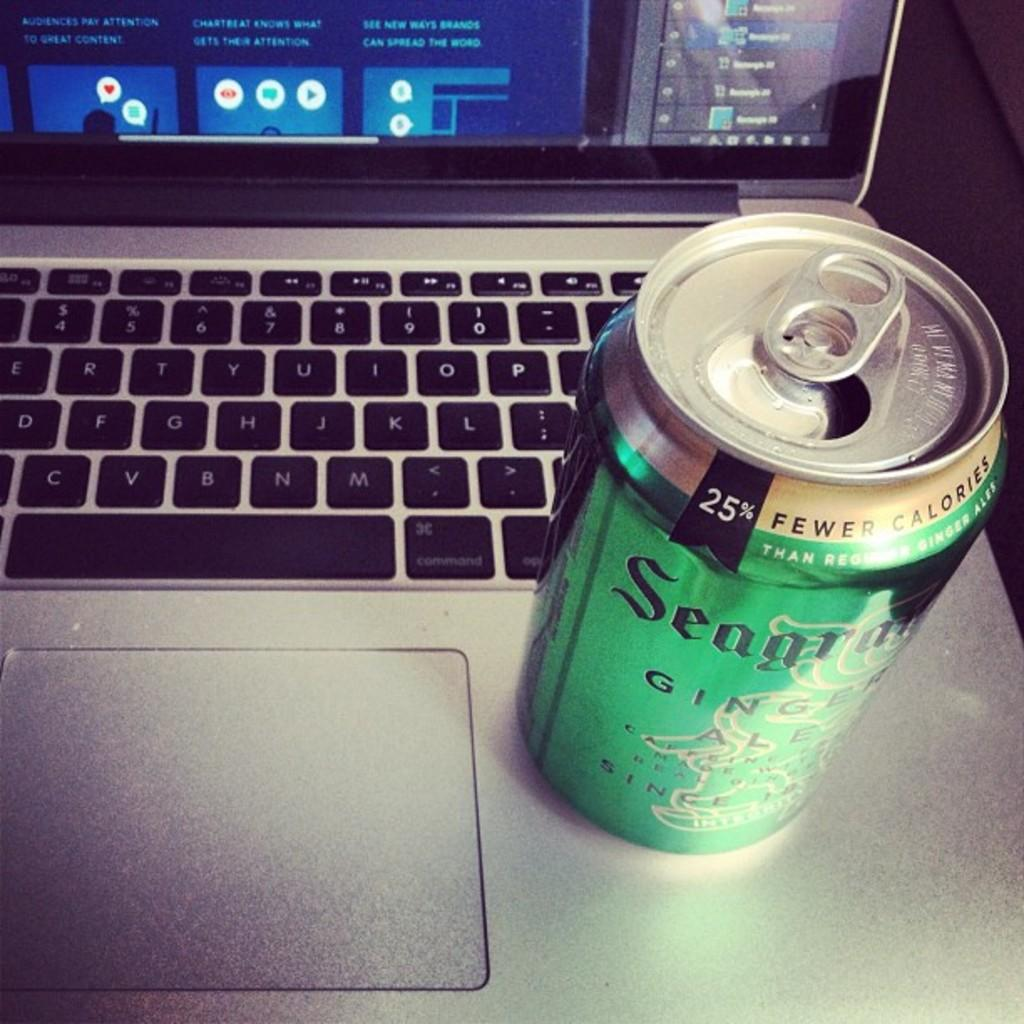<image>
Summarize the visual content of the image. An open can of Segrams Ginger-ale is sitting on an open laptop, next to the mouse pad. 